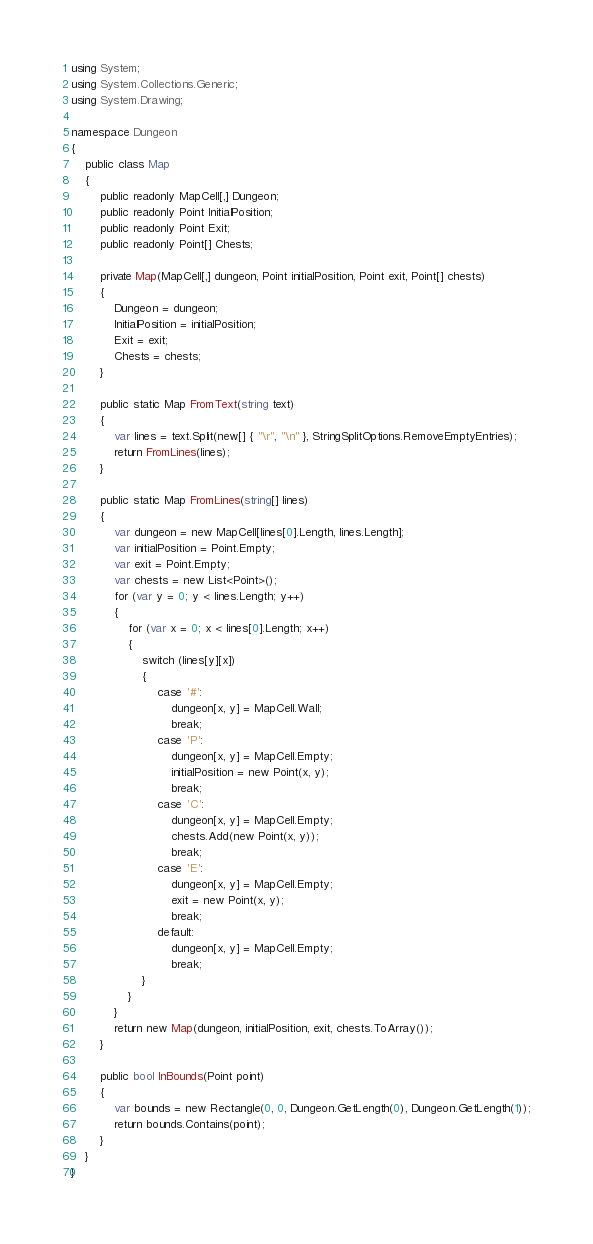<code> <loc_0><loc_0><loc_500><loc_500><_C#_>using System;
using System.Collections.Generic;
using System.Drawing;

namespace Dungeon
{
	public class Map
	{
		public readonly MapCell[,] Dungeon;
		public readonly Point InitialPosition;
		public readonly Point Exit;
		public readonly Point[] Chests;

		private Map(MapCell[,] dungeon, Point initialPosition, Point exit, Point[] chests)
		{
			Dungeon = dungeon;
			InitialPosition = initialPosition;
			Exit = exit;
			Chests = chests;
		}
		
		public static Map FromText(string text)
		{
			var lines = text.Split(new[] { "\r", "\n" }, StringSplitOptions.RemoveEmptyEntries);
			return FromLines(lines);
		}

		public static Map FromLines(string[] lines)
		{
			var dungeon = new MapCell[lines[0].Length, lines.Length];
			var initialPosition = Point.Empty;
			var exit = Point.Empty;
			var chests = new List<Point>();
			for (var y = 0; y < lines.Length; y++)
			{
				for (var x = 0; x < lines[0].Length; x++)
				{
					switch (lines[y][x])
					{
						case '#':
							dungeon[x, y] = MapCell.Wall;
							break;
						case 'P':
							dungeon[x, y] = MapCell.Empty;
							initialPosition = new Point(x, y);
							break;
						case 'C':
							dungeon[x, y] = MapCell.Empty;
							chests.Add(new Point(x, y));
							break;
						case 'E':
							dungeon[x, y] = MapCell.Empty;
							exit = new Point(x, y);
							break;
						default:
							dungeon[x, y] = MapCell.Empty;
							break;
					}
				}
			}
			return new Map(dungeon, initialPosition, exit, chests.ToArray());
		}

		public bool InBounds(Point point)
		{
			var bounds = new Rectangle(0, 0, Dungeon.GetLength(0), Dungeon.GetLength(1));
			return bounds.Contains(point);
		}
	}
}</code> 